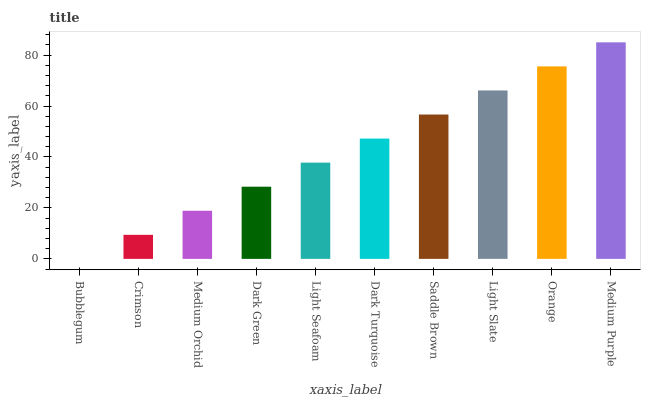Is Bubblegum the minimum?
Answer yes or no. Yes. Is Medium Purple the maximum?
Answer yes or no. Yes. Is Crimson the minimum?
Answer yes or no. No. Is Crimson the maximum?
Answer yes or no. No. Is Crimson greater than Bubblegum?
Answer yes or no. Yes. Is Bubblegum less than Crimson?
Answer yes or no. Yes. Is Bubblegum greater than Crimson?
Answer yes or no. No. Is Crimson less than Bubblegum?
Answer yes or no. No. Is Dark Turquoise the high median?
Answer yes or no. Yes. Is Light Seafoam the low median?
Answer yes or no. Yes. Is Light Seafoam the high median?
Answer yes or no. No. Is Medium Purple the low median?
Answer yes or no. No. 